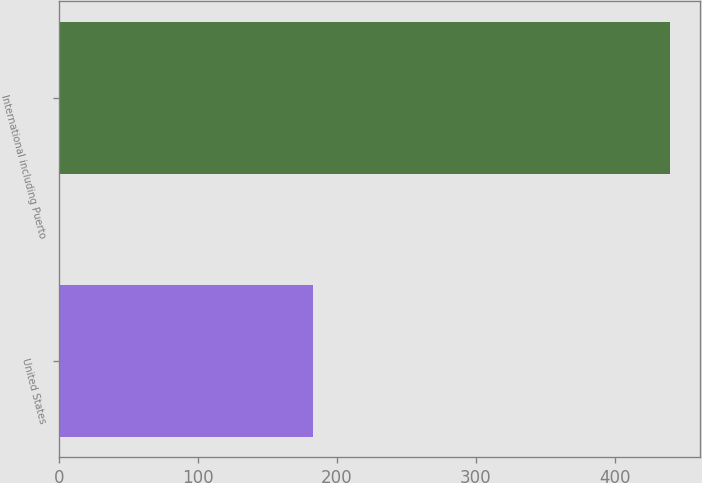<chart> <loc_0><loc_0><loc_500><loc_500><bar_chart><fcel>United States<fcel>International including Puerto<nl><fcel>182.8<fcel>439.6<nl></chart> 